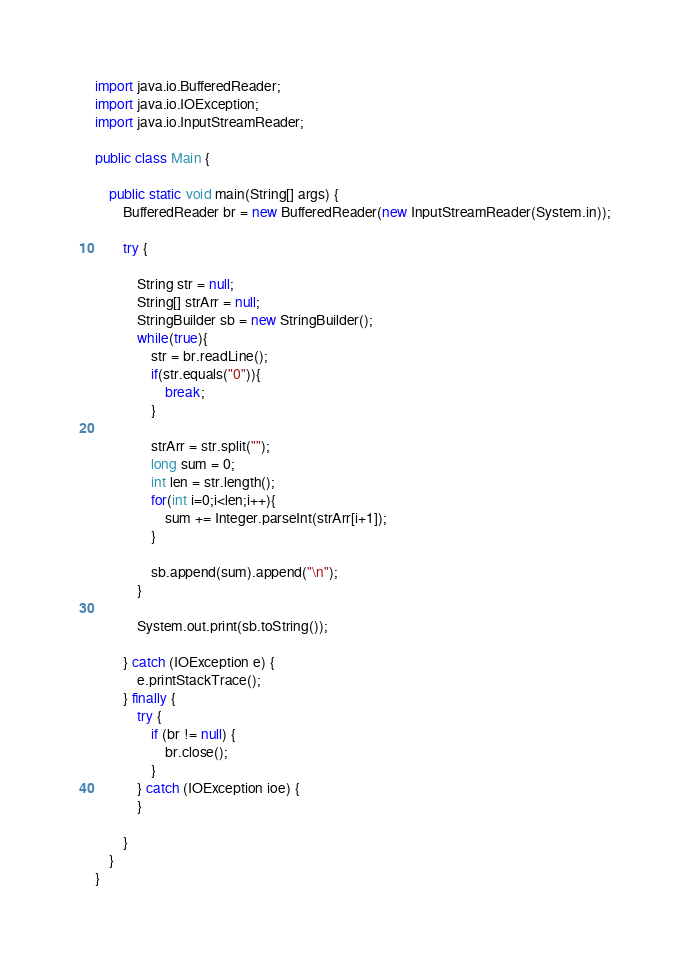<code> <loc_0><loc_0><loc_500><loc_500><_Java_>import java.io.BufferedReader;
import java.io.IOException;
import java.io.InputStreamReader;
 
public class Main {
 
    public static void main(String[] args) {
        BufferedReader br = new BufferedReader(new InputStreamReader(System.in));
 
        try {
 
            String str = null;
            String[] strArr = null;
            StringBuilder sb = new StringBuilder();
            while(true){
                str = br.readLine();
                if(str.equals("0")){
                    break;
                }
 
                strArr = str.split("");
                long sum = 0;
                int len = str.length();
                for(int i=0;i<len;i++){
                    sum += Integer.parseInt(strArr[i+1]);
                }
 
                sb.append(sum).append("\n");
            }
 
            System.out.print(sb.toString());
 
        } catch (IOException e) {
            e.printStackTrace();
        } finally {
            try {
                if (br != null) {
                    br.close();
                }
            } catch (IOException ioe) {
            }
 
        }
    }
}</code> 